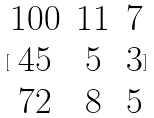Convert formula to latex. <formula><loc_0><loc_0><loc_500><loc_500>[ \begin{matrix} 1 0 0 & 1 1 & 7 \\ 4 5 & 5 & 3 \\ 7 2 & 8 & 5 \end{matrix} ]</formula> 